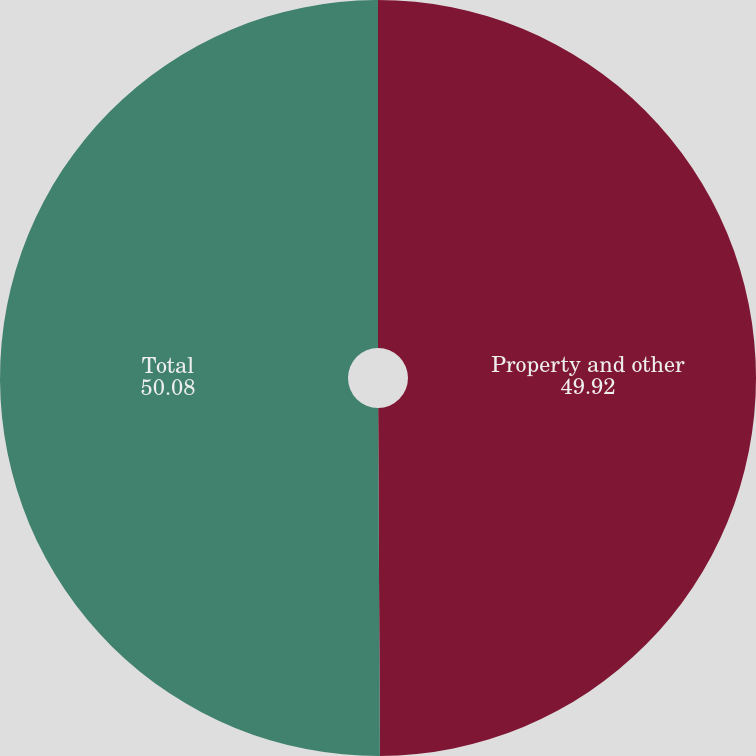Convert chart. <chart><loc_0><loc_0><loc_500><loc_500><pie_chart><fcel>Property and other<fcel>Total<nl><fcel>49.92%<fcel>50.08%<nl></chart> 